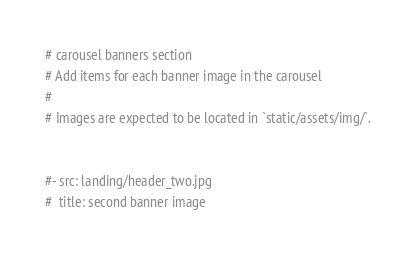<code> <loc_0><loc_0><loc_500><loc_500><_YAML_># carousel banners section
# Add items for each banner image in the carousel
#
# Images are expected to be located in `static/assets/img/`.


#- src: landing/header_two.jpg
#  title: second banner image
</code> 